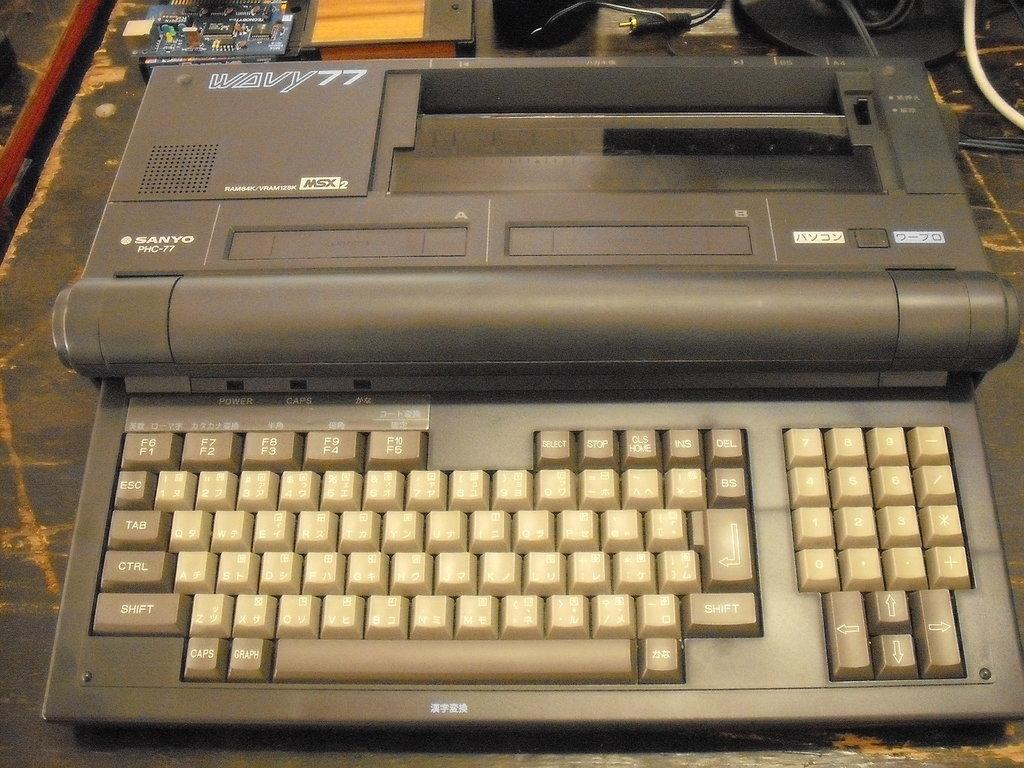<image>
Create a compact narrative representing the image presented. An old word processor had keys that go from F1 to F10. 